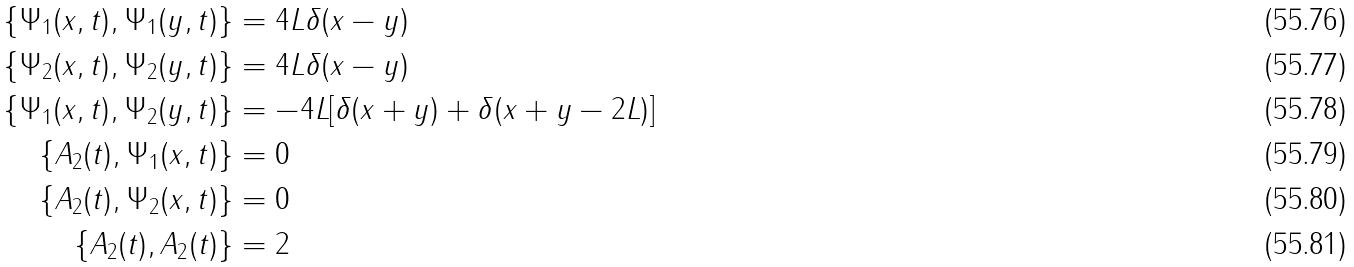<formula> <loc_0><loc_0><loc_500><loc_500>\{ \Psi _ { 1 } ( x , t ) , \Psi _ { 1 } ( y , t ) \} & = 4 L \delta ( x - y ) \\ \{ \Psi _ { 2 } ( x , t ) , \Psi _ { 2 } ( y , t ) \} & = 4 L \delta ( x - y ) \\ \{ \Psi _ { 1 } ( x , t ) , \Psi _ { 2 } ( y , t ) \} & = - 4 L [ \delta ( x + y ) + \delta ( x + y - 2 L ) ] \\ \{ A _ { 2 } ( t ) , \Psi _ { 1 } ( x , t ) \} & = 0 \\ \{ A _ { 2 } ( t ) , \Psi _ { 2 } ( x , t ) \} & = 0 \\ \{ A _ { 2 } ( t ) , A _ { 2 } ( t ) \} & = 2 \</formula> 